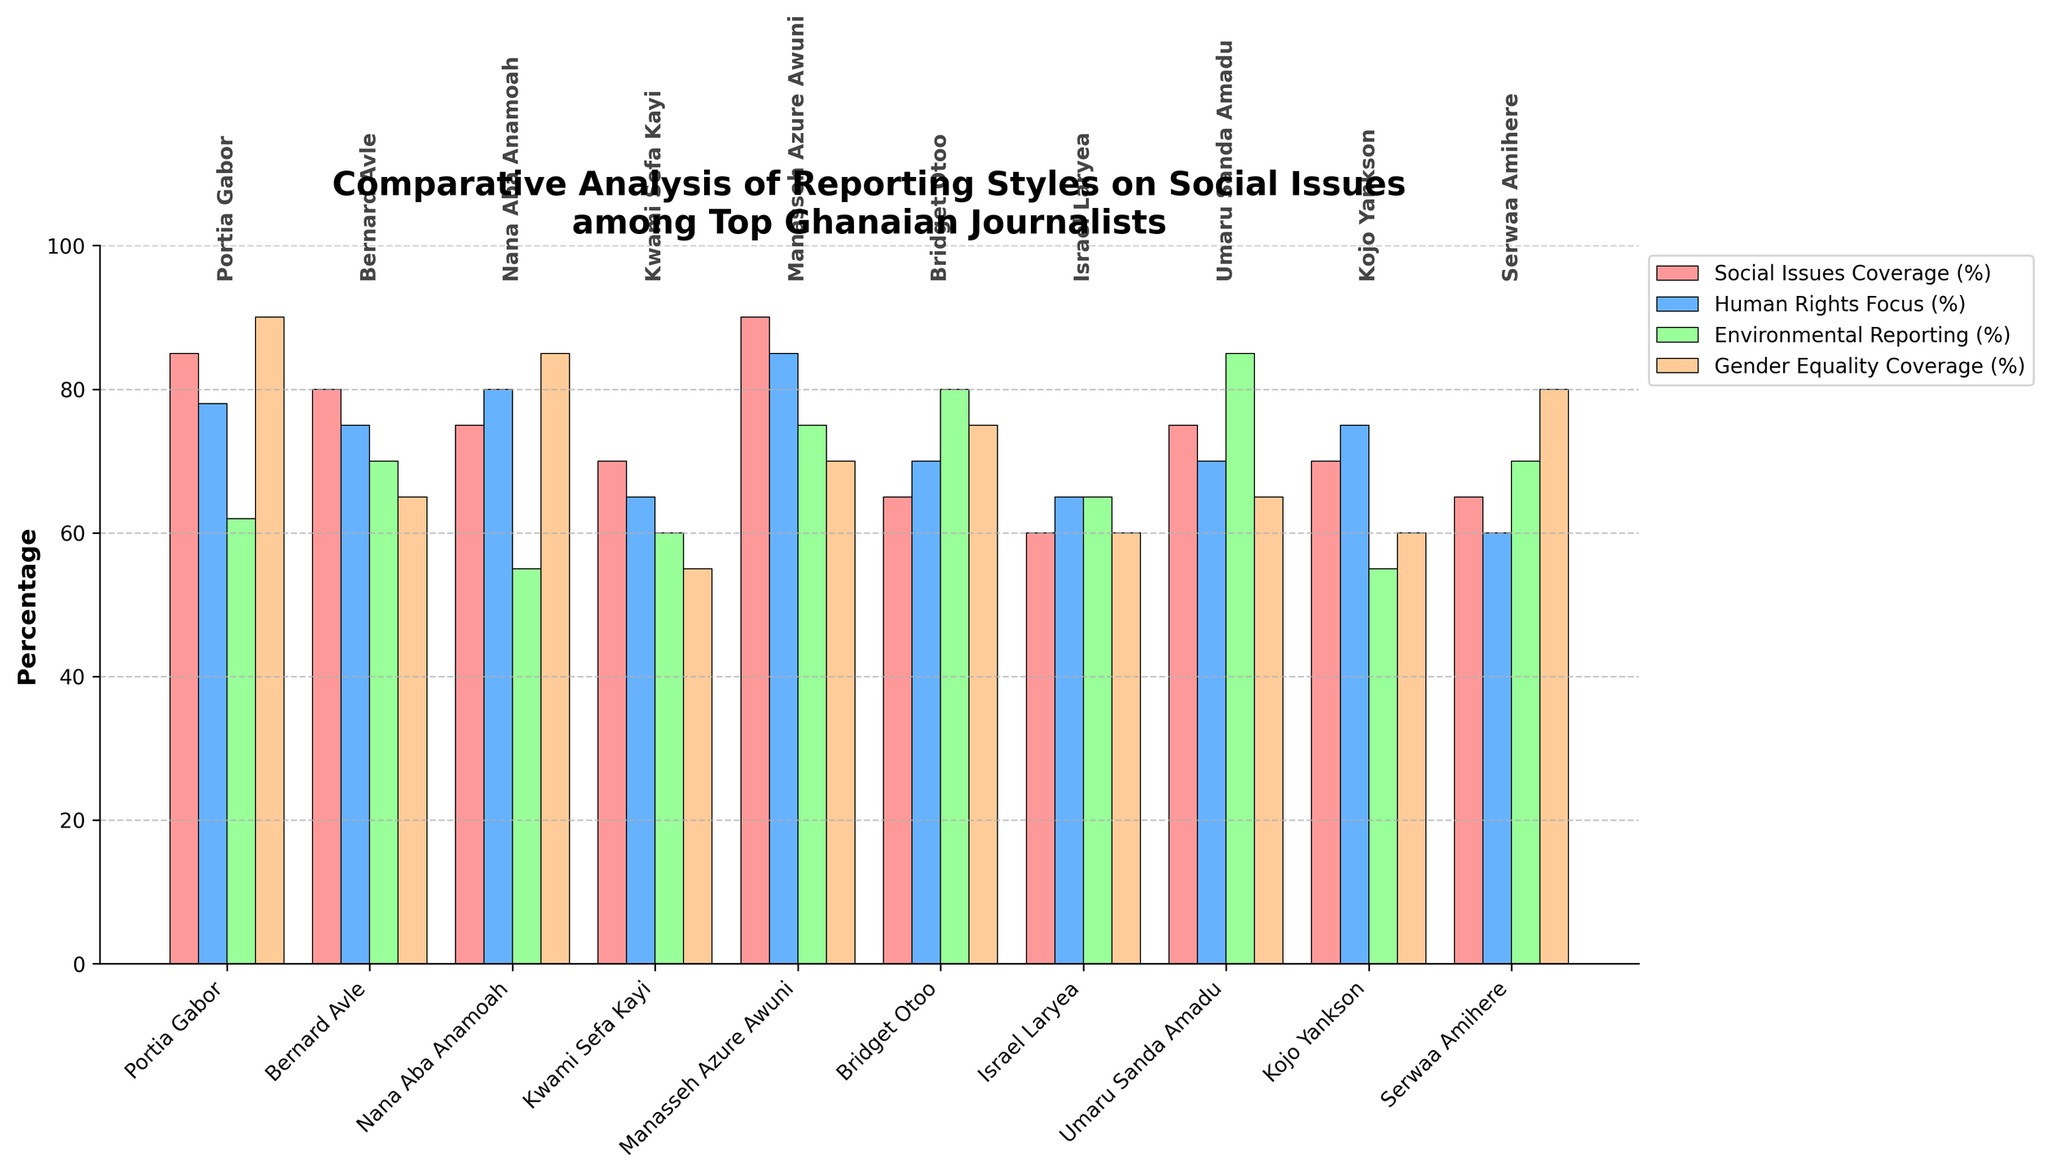Which journalist has the highest overall percentage in 'Social Issues Coverage (%)'? The tallest bar in the 'Social Issues Coverage (%)' category will indicate the journalist with the highest percentage. By comparing the heights of the bars representing 'Social Issues Coverage (%)' across all journalists, Manasseh Azure Awuni's bar is the tallest.
Answer: Manasseh Azure Awuni How does Portia Gabor's focus on 'Gender Equality Coverage (%)' compare to Bernard Avle's? By comparing the height of bars labeled 'Gender Equality Coverage (%)' for Portia Gabor and Bernard Avle, Portia Gabor's bar is taller at 90% compared to Bernard Avle's 65%.
Answer: Portia Gabor's focus is higher What is the average 'Human Rights Focus (%)' for Portia Gabor, Bernard Avle, and Nana Aba Anamoah? To find the average, sum the percentages of 'Human Rights Focus (%)' for Portia Gabor (78%), Bernard Avle (75%), and Nana Aba Anamoah (80%), which totals 233. Divide 233 by 3 to get the average.
Answer: 77.67% Which category shows the least variation among all journalists? By comparing the spread of the bars' heights for all categories visually, 'Social Issues Coverage (%)' appears to have the least variation in bar heights compared to other categories.
Answer: Social Issues Coverage (%) Who has the highest percentage in 'Environmental Reporting (%)' among all the journalists? By looking at the tallest bar in the 'Environmental Reporting (%)' category, Umaru Sanda Amadu's bar is the highest at 85%.
Answer: Umaru Sanda Amadu Is there a journalist who scores equally in both 'Social Issues Coverage (%)' and 'Gender Equality Coverage (%)'? By examining the bar heights for both categories, Serwaa Amihere scores equally with 65% in both 'Social Issues Coverage (%)' and 'Gender Equality Coverage (%)'.
Answer: Serwaa Amihere Which journalist has the most balanced coverage across all categories? By comparing the differences in bar heights for each journalist, Portia Gabor's bars are less varied in height and more balanced across all categories compared to others.
Answer: Portia Gabor What is the total percentage coverage for 'Environmental Reporting (%)' among all journalists? Summing up the percentages for 'Environmental Reporting (%)' from all journalists: 62 + 70 + 55 + 60 + 75 + 80 + 65 + 85 + 55 + 70 equals 677.
Answer: 677% How much higher is Manasseh Azure Awuni's 'Human Rights Focus (%)' compared to Israel Laryea's? Manasseh Azure Awuni has 85% and Israel Laryea has 65% in 'Human Rights Focus (%)'. Subtracting the two values gives us 85 - 65 = 20.
Answer: 20% Which journalist has the lowest percentage in any category and what is that percentage? By scanning for the shortest bar across all categories and journalists, Israel Laryea has the lowest percentage at 60% in 'Gender Equality Coverage (%)'.
Answer: Israel Laryea, 60% 